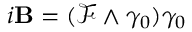<formula> <loc_0><loc_0><loc_500><loc_500>i B = ( { \mathcal { F } } \wedge \gamma _ { 0 } ) \gamma _ { 0 }</formula> 